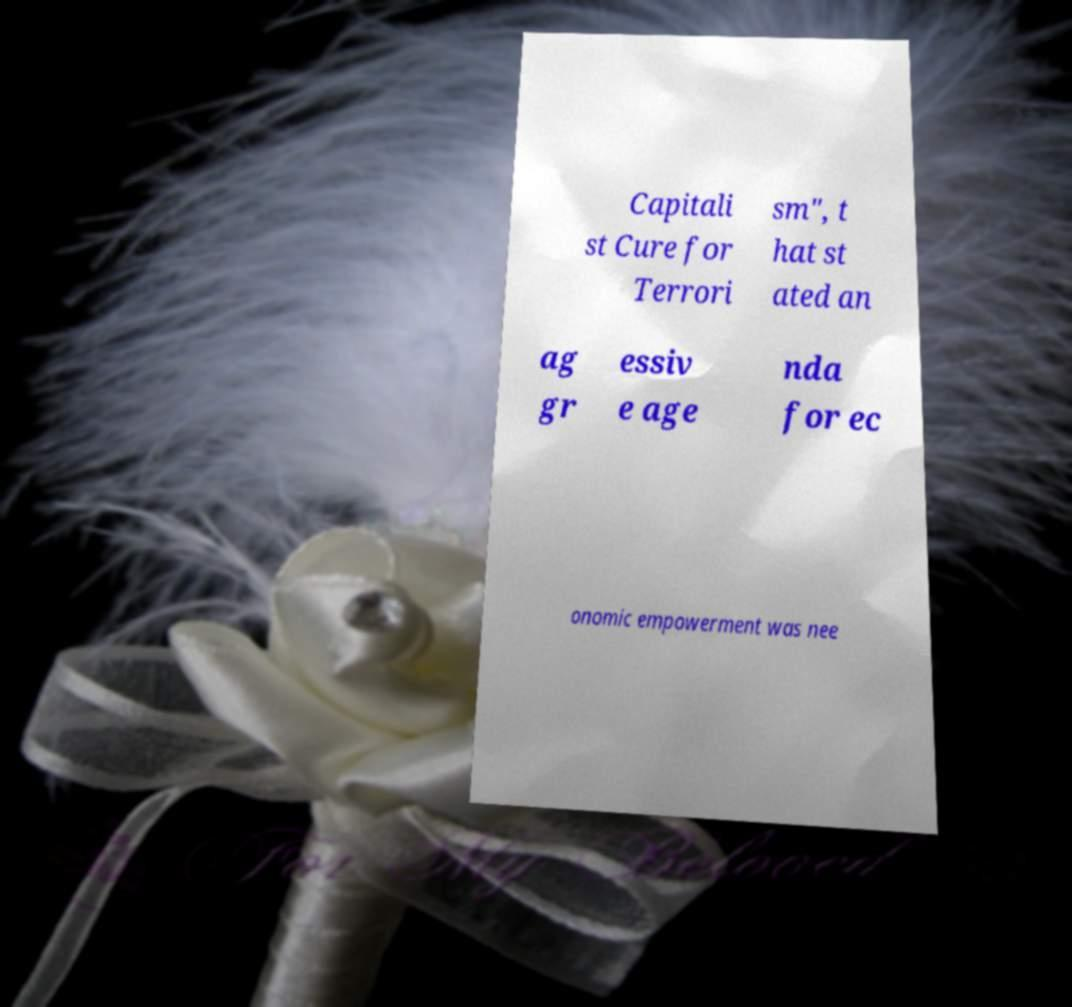Could you assist in decoding the text presented in this image and type it out clearly? Capitali st Cure for Terrori sm", t hat st ated an ag gr essiv e age nda for ec onomic empowerment was nee 